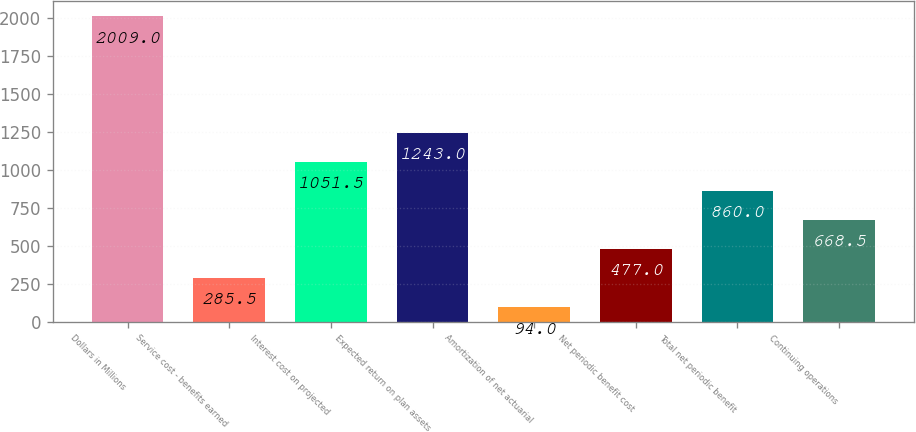<chart> <loc_0><loc_0><loc_500><loc_500><bar_chart><fcel>Dollars in Millions<fcel>Service cost - benefits earned<fcel>Interest cost on projected<fcel>Expected return on plan assets<fcel>Amortization of net actuarial<fcel>Net periodic benefit cost<fcel>Total net periodic benefit<fcel>Continuing operations<nl><fcel>2009<fcel>285.5<fcel>1051.5<fcel>1243<fcel>94<fcel>477<fcel>860<fcel>668.5<nl></chart> 